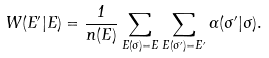Convert formula to latex. <formula><loc_0><loc_0><loc_500><loc_500>W ( E ^ { \prime } | E ) = \frac { 1 } { n ( E ) } \sum _ { E ( \sigma ) = E } \sum _ { E ( \sigma ^ { \prime } ) = E ^ { \prime } } \Gamma ( \sigma ^ { \prime } | \sigma ) .</formula> 